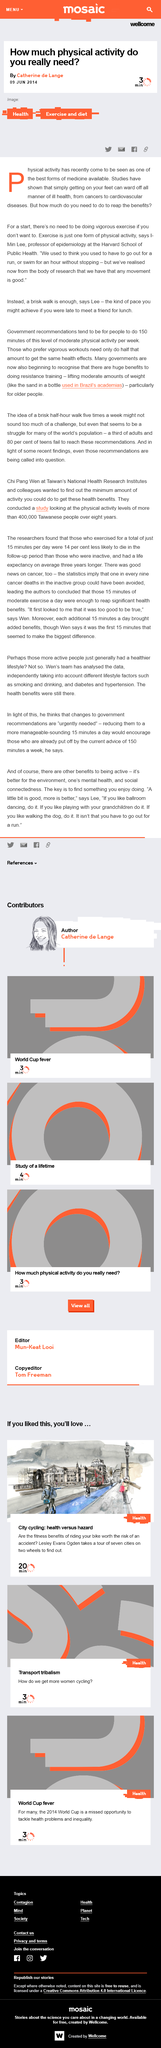Outline some significant characteristics in this image. The article was written by Catherine de Lange. I-Min Lee is a Professor of Epidemiology at the Harvard School of Public Health who is recognized for his expertise in the field. The article was published on June 9, 2014, and it discusses the topics of health, exercise, and diet. 